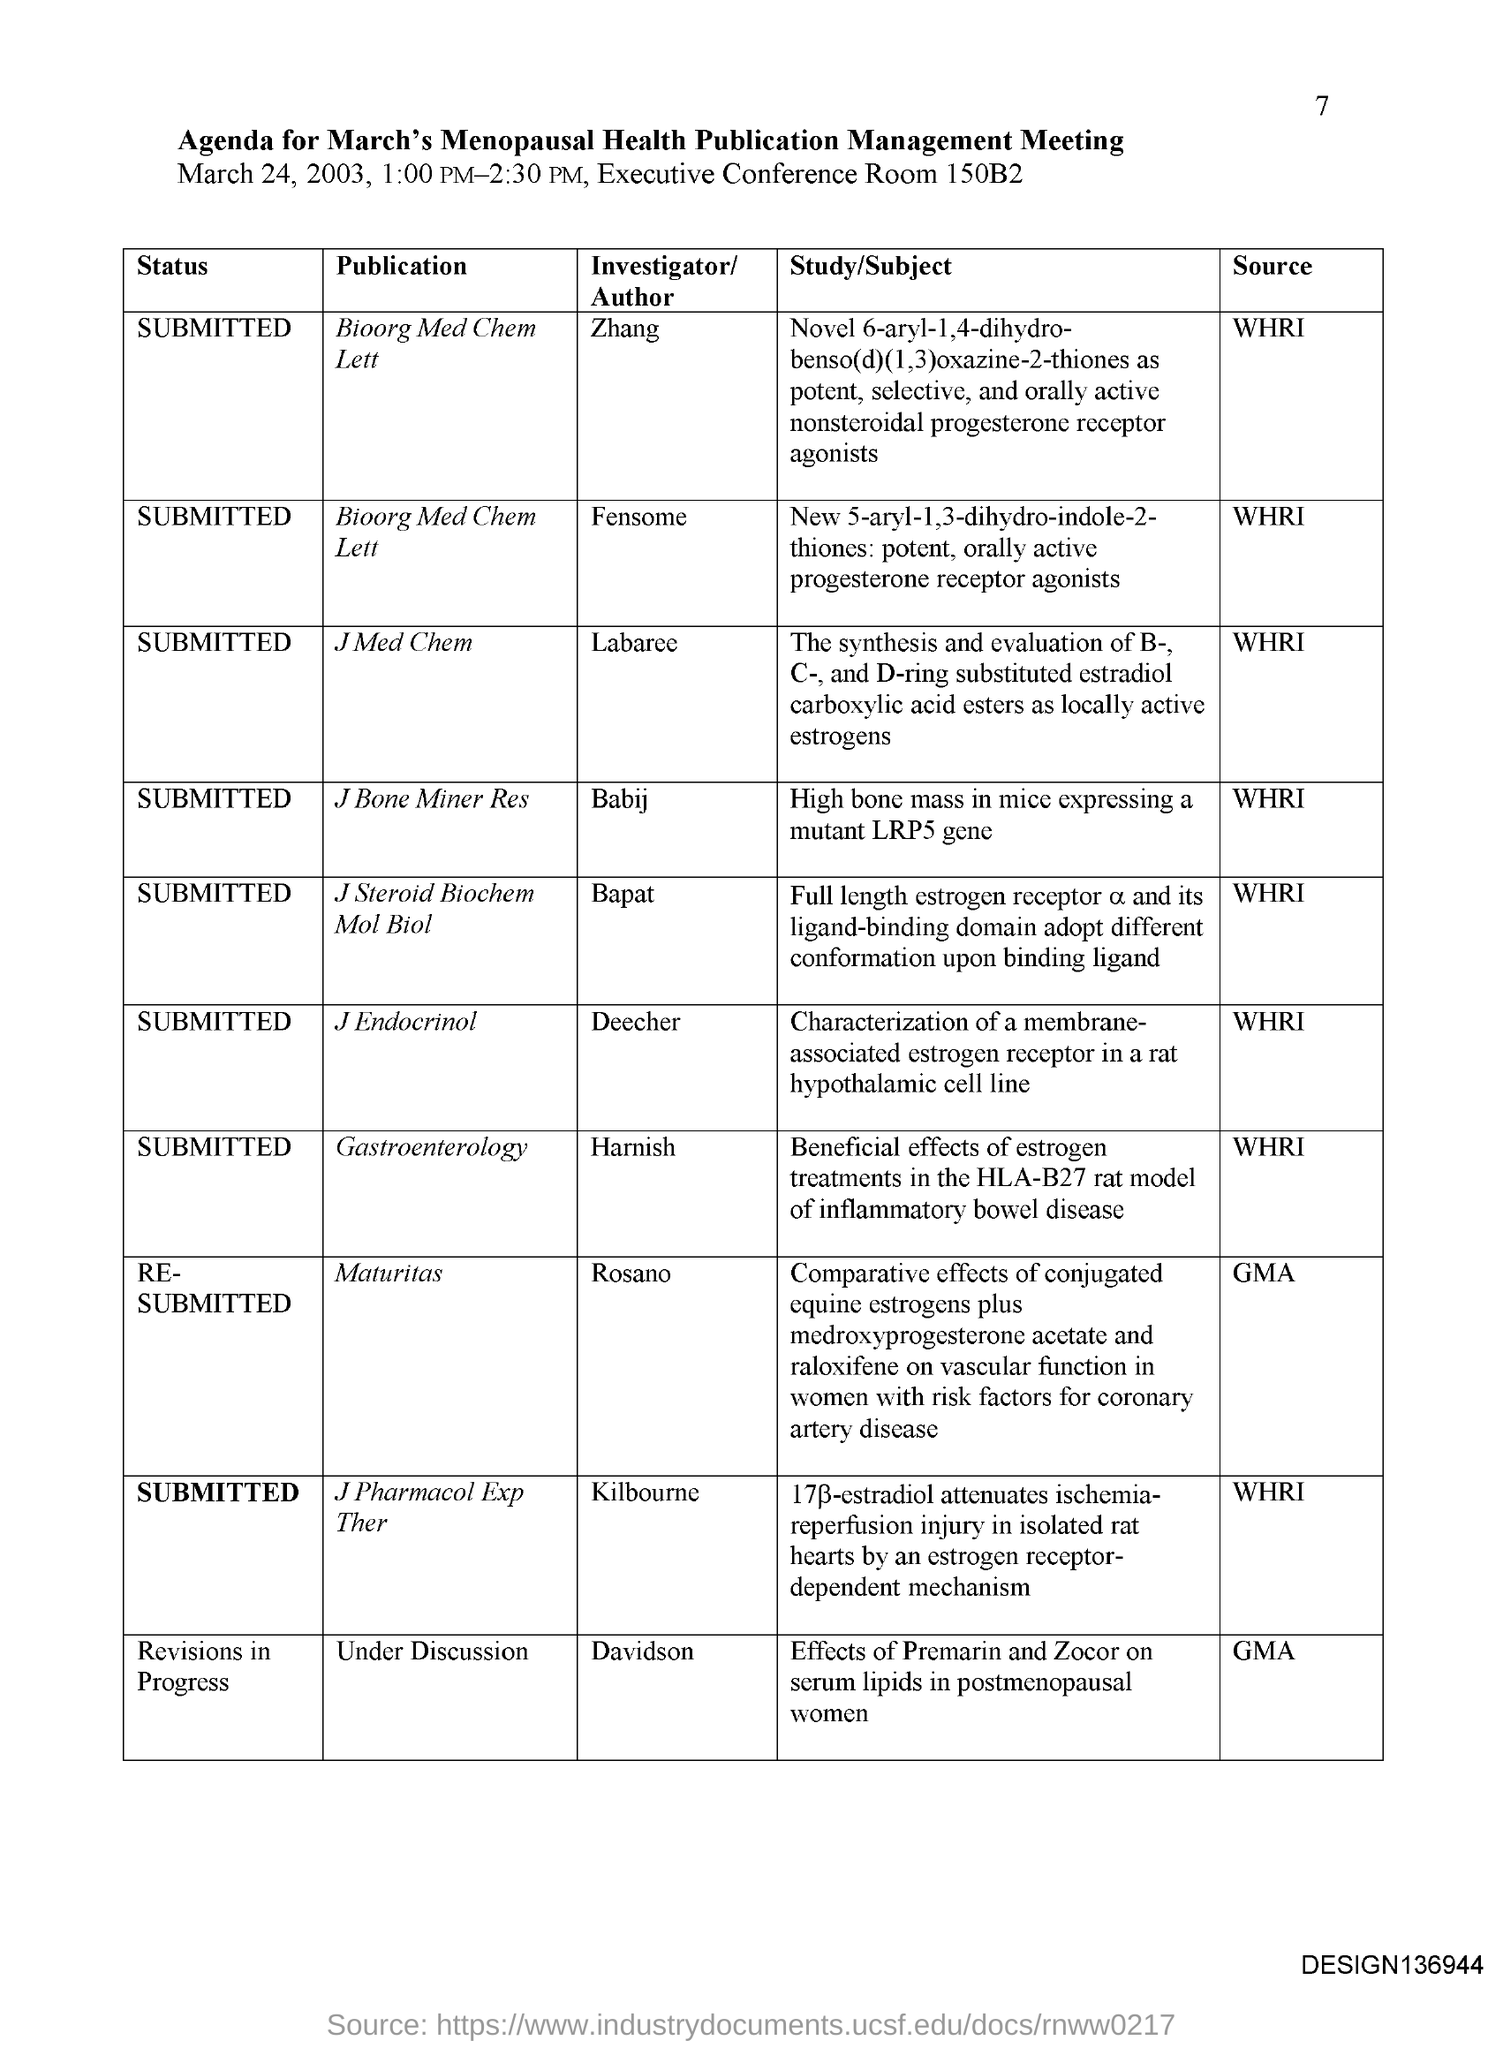What is the date on the document?
Offer a very short reply. March 24, 2003. Where is the meeting?
Provide a succinct answer. Executive conference room 150B2. Who is the investigator for the Publication "J Med Chem"?
Ensure brevity in your answer.  Labaree. Who is the investigator for the Publication "J Bone Miner Res"?
Your answer should be compact. Babij. Who is the investigator for the Publication "J Steroid Biochem Mol Biol"?
Ensure brevity in your answer.  Bapat. Who is the investigator for the Publication "J Endocrinol"?
Your response must be concise. Deecher. Who is the investigator for the Publication "Gastroenterology"?
Keep it short and to the point. Harnish. Who is the investigator for the Publication "Maturitas"?
Your answer should be compact. Rosano. Who is the investigator for the Publication "J Pharmacol Exp Ther"?
Offer a very short reply. Kilbourne. 